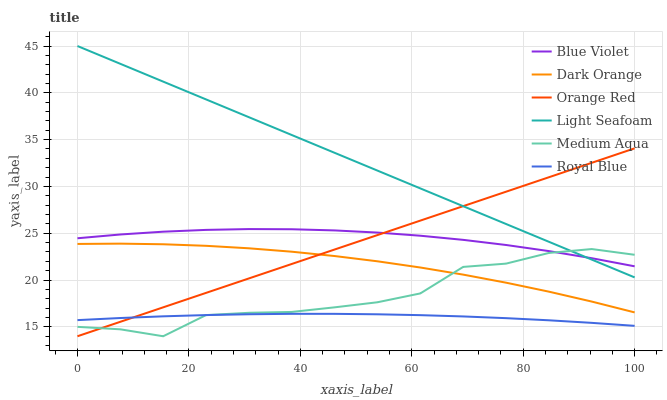Does Royal Blue have the minimum area under the curve?
Answer yes or no. Yes. Does Light Seafoam have the maximum area under the curve?
Answer yes or no. Yes. Does Medium Aqua have the minimum area under the curve?
Answer yes or no. No. Does Medium Aqua have the maximum area under the curve?
Answer yes or no. No. Is Orange Red the smoothest?
Answer yes or no. Yes. Is Medium Aqua the roughest?
Answer yes or no. Yes. Is Royal Blue the smoothest?
Answer yes or no. No. Is Royal Blue the roughest?
Answer yes or no. No. Does Medium Aqua have the lowest value?
Answer yes or no. Yes. Does Royal Blue have the lowest value?
Answer yes or no. No. Does Light Seafoam have the highest value?
Answer yes or no. Yes. Does Medium Aqua have the highest value?
Answer yes or no. No. Is Royal Blue less than Light Seafoam?
Answer yes or no. Yes. Is Blue Violet greater than Dark Orange?
Answer yes or no. Yes. Does Orange Red intersect Light Seafoam?
Answer yes or no. Yes. Is Orange Red less than Light Seafoam?
Answer yes or no. No. Is Orange Red greater than Light Seafoam?
Answer yes or no. No. Does Royal Blue intersect Light Seafoam?
Answer yes or no. No. 